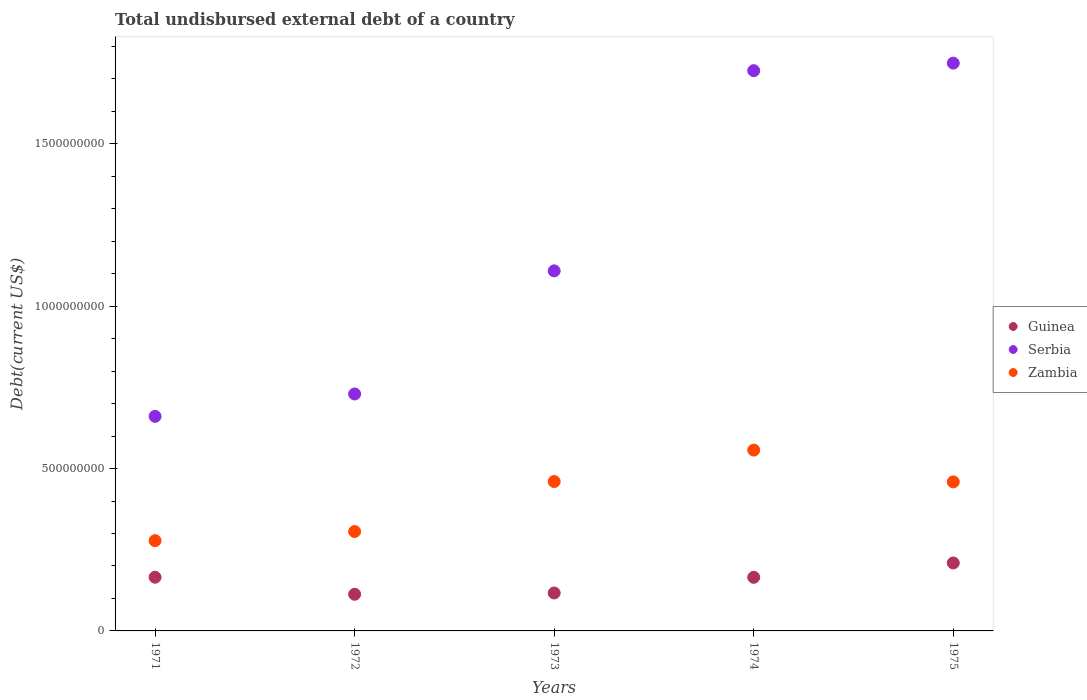What is the total undisbursed external debt in Serbia in 1972?
Ensure brevity in your answer.  7.30e+08. Across all years, what is the maximum total undisbursed external debt in Serbia?
Ensure brevity in your answer.  1.75e+09. Across all years, what is the minimum total undisbursed external debt in Serbia?
Offer a very short reply. 6.61e+08. In which year was the total undisbursed external debt in Serbia maximum?
Your answer should be very brief. 1975. In which year was the total undisbursed external debt in Zambia minimum?
Provide a succinct answer. 1971. What is the total total undisbursed external debt in Serbia in the graph?
Make the answer very short. 5.97e+09. What is the difference between the total undisbursed external debt in Serbia in 1974 and that in 1975?
Your answer should be compact. -2.32e+07. What is the difference between the total undisbursed external debt in Guinea in 1972 and the total undisbursed external debt in Serbia in 1974?
Give a very brief answer. -1.61e+09. What is the average total undisbursed external debt in Zambia per year?
Provide a succinct answer. 4.12e+08. In the year 1975, what is the difference between the total undisbursed external debt in Guinea and total undisbursed external debt in Zambia?
Offer a very short reply. -2.50e+08. In how many years, is the total undisbursed external debt in Zambia greater than 800000000 US$?
Provide a succinct answer. 0. What is the ratio of the total undisbursed external debt in Guinea in 1971 to that in 1972?
Make the answer very short. 1.46. Is the total undisbursed external debt in Guinea in 1971 less than that in 1974?
Ensure brevity in your answer.  No. What is the difference between the highest and the second highest total undisbursed external debt in Guinea?
Keep it short and to the point. 4.39e+07. What is the difference between the highest and the lowest total undisbursed external debt in Serbia?
Provide a short and direct response. 1.09e+09. Is the sum of the total undisbursed external debt in Guinea in 1971 and 1972 greater than the maximum total undisbursed external debt in Zambia across all years?
Provide a succinct answer. No. Is it the case that in every year, the sum of the total undisbursed external debt in Zambia and total undisbursed external debt in Serbia  is greater than the total undisbursed external debt in Guinea?
Provide a succinct answer. Yes. Is the total undisbursed external debt in Serbia strictly greater than the total undisbursed external debt in Zambia over the years?
Your answer should be very brief. Yes. How many dotlines are there?
Your answer should be very brief. 3. Does the graph contain any zero values?
Offer a terse response. No. Does the graph contain grids?
Offer a very short reply. No. Where does the legend appear in the graph?
Give a very brief answer. Center right. What is the title of the graph?
Your response must be concise. Total undisbursed external debt of a country. What is the label or title of the Y-axis?
Offer a very short reply. Debt(current US$). What is the Debt(current US$) of Guinea in 1971?
Your response must be concise. 1.65e+08. What is the Debt(current US$) of Serbia in 1971?
Your response must be concise. 6.61e+08. What is the Debt(current US$) of Zambia in 1971?
Keep it short and to the point. 2.78e+08. What is the Debt(current US$) of Guinea in 1972?
Provide a short and direct response. 1.13e+08. What is the Debt(current US$) in Serbia in 1972?
Ensure brevity in your answer.  7.30e+08. What is the Debt(current US$) of Zambia in 1972?
Your response must be concise. 3.06e+08. What is the Debt(current US$) in Guinea in 1973?
Your response must be concise. 1.17e+08. What is the Debt(current US$) of Serbia in 1973?
Ensure brevity in your answer.  1.11e+09. What is the Debt(current US$) of Zambia in 1973?
Offer a very short reply. 4.60e+08. What is the Debt(current US$) of Guinea in 1974?
Give a very brief answer. 1.65e+08. What is the Debt(current US$) of Serbia in 1974?
Offer a very short reply. 1.73e+09. What is the Debt(current US$) of Zambia in 1974?
Give a very brief answer. 5.57e+08. What is the Debt(current US$) of Guinea in 1975?
Your answer should be compact. 2.09e+08. What is the Debt(current US$) in Serbia in 1975?
Your answer should be compact. 1.75e+09. What is the Debt(current US$) of Zambia in 1975?
Make the answer very short. 4.59e+08. Across all years, what is the maximum Debt(current US$) of Guinea?
Your answer should be compact. 2.09e+08. Across all years, what is the maximum Debt(current US$) of Serbia?
Provide a succinct answer. 1.75e+09. Across all years, what is the maximum Debt(current US$) in Zambia?
Your answer should be very brief. 5.57e+08. Across all years, what is the minimum Debt(current US$) of Guinea?
Provide a short and direct response. 1.13e+08. Across all years, what is the minimum Debt(current US$) in Serbia?
Offer a terse response. 6.61e+08. Across all years, what is the minimum Debt(current US$) of Zambia?
Offer a very short reply. 2.78e+08. What is the total Debt(current US$) of Guinea in the graph?
Ensure brevity in your answer.  7.70e+08. What is the total Debt(current US$) of Serbia in the graph?
Give a very brief answer. 5.97e+09. What is the total Debt(current US$) of Zambia in the graph?
Make the answer very short. 2.06e+09. What is the difference between the Debt(current US$) in Guinea in 1971 and that in 1972?
Offer a very short reply. 5.25e+07. What is the difference between the Debt(current US$) of Serbia in 1971 and that in 1972?
Offer a terse response. -6.89e+07. What is the difference between the Debt(current US$) in Zambia in 1971 and that in 1972?
Make the answer very short. -2.82e+07. What is the difference between the Debt(current US$) of Guinea in 1971 and that in 1973?
Your answer should be very brief. 4.86e+07. What is the difference between the Debt(current US$) in Serbia in 1971 and that in 1973?
Make the answer very short. -4.48e+08. What is the difference between the Debt(current US$) of Zambia in 1971 and that in 1973?
Your response must be concise. -1.82e+08. What is the difference between the Debt(current US$) of Guinea in 1971 and that in 1974?
Your answer should be compact. 3.37e+05. What is the difference between the Debt(current US$) of Serbia in 1971 and that in 1974?
Offer a very short reply. -1.06e+09. What is the difference between the Debt(current US$) in Zambia in 1971 and that in 1974?
Provide a succinct answer. -2.79e+08. What is the difference between the Debt(current US$) of Guinea in 1971 and that in 1975?
Provide a succinct answer. -4.39e+07. What is the difference between the Debt(current US$) in Serbia in 1971 and that in 1975?
Your answer should be very brief. -1.09e+09. What is the difference between the Debt(current US$) in Zambia in 1971 and that in 1975?
Provide a succinct answer. -1.81e+08. What is the difference between the Debt(current US$) in Guinea in 1972 and that in 1973?
Give a very brief answer. -3.91e+06. What is the difference between the Debt(current US$) in Serbia in 1972 and that in 1973?
Ensure brevity in your answer.  -3.79e+08. What is the difference between the Debt(current US$) in Zambia in 1972 and that in 1973?
Give a very brief answer. -1.54e+08. What is the difference between the Debt(current US$) in Guinea in 1972 and that in 1974?
Ensure brevity in your answer.  -5.21e+07. What is the difference between the Debt(current US$) of Serbia in 1972 and that in 1974?
Keep it short and to the point. -9.96e+08. What is the difference between the Debt(current US$) of Zambia in 1972 and that in 1974?
Provide a succinct answer. -2.51e+08. What is the difference between the Debt(current US$) of Guinea in 1972 and that in 1975?
Your response must be concise. -9.64e+07. What is the difference between the Debt(current US$) of Serbia in 1972 and that in 1975?
Offer a very short reply. -1.02e+09. What is the difference between the Debt(current US$) in Zambia in 1972 and that in 1975?
Provide a short and direct response. -1.53e+08. What is the difference between the Debt(current US$) in Guinea in 1973 and that in 1974?
Ensure brevity in your answer.  -4.82e+07. What is the difference between the Debt(current US$) of Serbia in 1973 and that in 1974?
Provide a short and direct response. -6.17e+08. What is the difference between the Debt(current US$) in Zambia in 1973 and that in 1974?
Ensure brevity in your answer.  -9.68e+07. What is the difference between the Debt(current US$) in Guinea in 1973 and that in 1975?
Give a very brief answer. -9.25e+07. What is the difference between the Debt(current US$) in Serbia in 1973 and that in 1975?
Ensure brevity in your answer.  -6.40e+08. What is the difference between the Debt(current US$) in Zambia in 1973 and that in 1975?
Make the answer very short. 1.12e+06. What is the difference between the Debt(current US$) in Guinea in 1974 and that in 1975?
Your answer should be very brief. -4.42e+07. What is the difference between the Debt(current US$) of Serbia in 1974 and that in 1975?
Ensure brevity in your answer.  -2.32e+07. What is the difference between the Debt(current US$) of Zambia in 1974 and that in 1975?
Provide a succinct answer. 9.79e+07. What is the difference between the Debt(current US$) of Guinea in 1971 and the Debt(current US$) of Serbia in 1972?
Your answer should be compact. -5.64e+08. What is the difference between the Debt(current US$) of Guinea in 1971 and the Debt(current US$) of Zambia in 1972?
Make the answer very short. -1.41e+08. What is the difference between the Debt(current US$) in Serbia in 1971 and the Debt(current US$) in Zambia in 1972?
Your response must be concise. 3.55e+08. What is the difference between the Debt(current US$) in Guinea in 1971 and the Debt(current US$) in Serbia in 1973?
Keep it short and to the point. -9.44e+08. What is the difference between the Debt(current US$) of Guinea in 1971 and the Debt(current US$) of Zambia in 1973?
Provide a succinct answer. -2.95e+08. What is the difference between the Debt(current US$) in Serbia in 1971 and the Debt(current US$) in Zambia in 1973?
Keep it short and to the point. 2.01e+08. What is the difference between the Debt(current US$) of Guinea in 1971 and the Debt(current US$) of Serbia in 1974?
Your answer should be compact. -1.56e+09. What is the difference between the Debt(current US$) in Guinea in 1971 and the Debt(current US$) in Zambia in 1974?
Provide a short and direct response. -3.92e+08. What is the difference between the Debt(current US$) in Serbia in 1971 and the Debt(current US$) in Zambia in 1974?
Keep it short and to the point. 1.04e+08. What is the difference between the Debt(current US$) in Guinea in 1971 and the Debt(current US$) in Serbia in 1975?
Make the answer very short. -1.58e+09. What is the difference between the Debt(current US$) in Guinea in 1971 and the Debt(current US$) in Zambia in 1975?
Keep it short and to the point. -2.94e+08. What is the difference between the Debt(current US$) of Serbia in 1971 and the Debt(current US$) of Zambia in 1975?
Offer a very short reply. 2.02e+08. What is the difference between the Debt(current US$) in Guinea in 1972 and the Debt(current US$) in Serbia in 1973?
Ensure brevity in your answer.  -9.96e+08. What is the difference between the Debt(current US$) in Guinea in 1972 and the Debt(current US$) in Zambia in 1973?
Provide a succinct answer. -3.47e+08. What is the difference between the Debt(current US$) of Serbia in 1972 and the Debt(current US$) of Zambia in 1973?
Provide a short and direct response. 2.70e+08. What is the difference between the Debt(current US$) in Guinea in 1972 and the Debt(current US$) in Serbia in 1974?
Offer a very short reply. -1.61e+09. What is the difference between the Debt(current US$) of Guinea in 1972 and the Debt(current US$) of Zambia in 1974?
Offer a terse response. -4.44e+08. What is the difference between the Debt(current US$) in Serbia in 1972 and the Debt(current US$) in Zambia in 1974?
Your answer should be compact. 1.73e+08. What is the difference between the Debt(current US$) in Guinea in 1972 and the Debt(current US$) in Serbia in 1975?
Provide a succinct answer. -1.64e+09. What is the difference between the Debt(current US$) in Guinea in 1972 and the Debt(current US$) in Zambia in 1975?
Provide a short and direct response. -3.46e+08. What is the difference between the Debt(current US$) of Serbia in 1972 and the Debt(current US$) of Zambia in 1975?
Provide a succinct answer. 2.71e+08. What is the difference between the Debt(current US$) in Guinea in 1973 and the Debt(current US$) in Serbia in 1974?
Provide a short and direct response. -1.61e+09. What is the difference between the Debt(current US$) in Guinea in 1973 and the Debt(current US$) in Zambia in 1974?
Ensure brevity in your answer.  -4.40e+08. What is the difference between the Debt(current US$) in Serbia in 1973 and the Debt(current US$) in Zambia in 1974?
Provide a short and direct response. 5.52e+08. What is the difference between the Debt(current US$) in Guinea in 1973 and the Debt(current US$) in Serbia in 1975?
Make the answer very short. -1.63e+09. What is the difference between the Debt(current US$) in Guinea in 1973 and the Debt(current US$) in Zambia in 1975?
Your answer should be very brief. -3.42e+08. What is the difference between the Debt(current US$) of Serbia in 1973 and the Debt(current US$) of Zambia in 1975?
Make the answer very short. 6.50e+08. What is the difference between the Debt(current US$) in Guinea in 1974 and the Debt(current US$) in Serbia in 1975?
Offer a very short reply. -1.58e+09. What is the difference between the Debt(current US$) in Guinea in 1974 and the Debt(current US$) in Zambia in 1975?
Keep it short and to the point. -2.94e+08. What is the difference between the Debt(current US$) in Serbia in 1974 and the Debt(current US$) in Zambia in 1975?
Make the answer very short. 1.27e+09. What is the average Debt(current US$) in Guinea per year?
Offer a terse response. 1.54e+08. What is the average Debt(current US$) in Serbia per year?
Your answer should be very brief. 1.19e+09. What is the average Debt(current US$) in Zambia per year?
Your response must be concise. 4.12e+08. In the year 1971, what is the difference between the Debt(current US$) of Guinea and Debt(current US$) of Serbia?
Make the answer very short. -4.95e+08. In the year 1971, what is the difference between the Debt(current US$) of Guinea and Debt(current US$) of Zambia?
Your answer should be very brief. -1.13e+08. In the year 1971, what is the difference between the Debt(current US$) in Serbia and Debt(current US$) in Zambia?
Your answer should be very brief. 3.83e+08. In the year 1972, what is the difference between the Debt(current US$) of Guinea and Debt(current US$) of Serbia?
Give a very brief answer. -6.17e+08. In the year 1972, what is the difference between the Debt(current US$) of Guinea and Debt(current US$) of Zambia?
Provide a succinct answer. -1.93e+08. In the year 1972, what is the difference between the Debt(current US$) of Serbia and Debt(current US$) of Zambia?
Your answer should be compact. 4.24e+08. In the year 1973, what is the difference between the Debt(current US$) of Guinea and Debt(current US$) of Serbia?
Your response must be concise. -9.92e+08. In the year 1973, what is the difference between the Debt(current US$) of Guinea and Debt(current US$) of Zambia?
Offer a terse response. -3.43e+08. In the year 1973, what is the difference between the Debt(current US$) in Serbia and Debt(current US$) in Zambia?
Give a very brief answer. 6.49e+08. In the year 1974, what is the difference between the Debt(current US$) of Guinea and Debt(current US$) of Serbia?
Your answer should be very brief. -1.56e+09. In the year 1974, what is the difference between the Debt(current US$) in Guinea and Debt(current US$) in Zambia?
Give a very brief answer. -3.92e+08. In the year 1974, what is the difference between the Debt(current US$) of Serbia and Debt(current US$) of Zambia?
Your answer should be compact. 1.17e+09. In the year 1975, what is the difference between the Debt(current US$) in Guinea and Debt(current US$) in Serbia?
Provide a short and direct response. -1.54e+09. In the year 1975, what is the difference between the Debt(current US$) of Guinea and Debt(current US$) of Zambia?
Ensure brevity in your answer.  -2.50e+08. In the year 1975, what is the difference between the Debt(current US$) of Serbia and Debt(current US$) of Zambia?
Make the answer very short. 1.29e+09. What is the ratio of the Debt(current US$) of Guinea in 1971 to that in 1972?
Your response must be concise. 1.46. What is the ratio of the Debt(current US$) of Serbia in 1971 to that in 1972?
Ensure brevity in your answer.  0.91. What is the ratio of the Debt(current US$) of Zambia in 1971 to that in 1972?
Give a very brief answer. 0.91. What is the ratio of the Debt(current US$) in Guinea in 1971 to that in 1973?
Offer a very short reply. 1.42. What is the ratio of the Debt(current US$) of Serbia in 1971 to that in 1973?
Ensure brevity in your answer.  0.6. What is the ratio of the Debt(current US$) in Zambia in 1971 to that in 1973?
Make the answer very short. 0.6. What is the ratio of the Debt(current US$) of Guinea in 1971 to that in 1974?
Provide a succinct answer. 1. What is the ratio of the Debt(current US$) of Serbia in 1971 to that in 1974?
Offer a terse response. 0.38. What is the ratio of the Debt(current US$) in Zambia in 1971 to that in 1974?
Provide a short and direct response. 0.5. What is the ratio of the Debt(current US$) of Guinea in 1971 to that in 1975?
Offer a very short reply. 0.79. What is the ratio of the Debt(current US$) of Serbia in 1971 to that in 1975?
Offer a very short reply. 0.38. What is the ratio of the Debt(current US$) in Zambia in 1971 to that in 1975?
Provide a short and direct response. 0.61. What is the ratio of the Debt(current US$) in Guinea in 1972 to that in 1973?
Give a very brief answer. 0.97. What is the ratio of the Debt(current US$) of Serbia in 1972 to that in 1973?
Offer a very short reply. 0.66. What is the ratio of the Debt(current US$) in Zambia in 1972 to that in 1973?
Ensure brevity in your answer.  0.67. What is the ratio of the Debt(current US$) of Guinea in 1972 to that in 1974?
Provide a short and direct response. 0.68. What is the ratio of the Debt(current US$) in Serbia in 1972 to that in 1974?
Provide a succinct answer. 0.42. What is the ratio of the Debt(current US$) of Zambia in 1972 to that in 1974?
Provide a succinct answer. 0.55. What is the ratio of the Debt(current US$) in Guinea in 1972 to that in 1975?
Your answer should be compact. 0.54. What is the ratio of the Debt(current US$) of Serbia in 1972 to that in 1975?
Offer a terse response. 0.42. What is the ratio of the Debt(current US$) in Zambia in 1972 to that in 1975?
Offer a very short reply. 0.67. What is the ratio of the Debt(current US$) of Guinea in 1973 to that in 1974?
Offer a very short reply. 0.71. What is the ratio of the Debt(current US$) of Serbia in 1973 to that in 1974?
Give a very brief answer. 0.64. What is the ratio of the Debt(current US$) in Zambia in 1973 to that in 1974?
Ensure brevity in your answer.  0.83. What is the ratio of the Debt(current US$) in Guinea in 1973 to that in 1975?
Keep it short and to the point. 0.56. What is the ratio of the Debt(current US$) in Serbia in 1973 to that in 1975?
Your answer should be compact. 0.63. What is the ratio of the Debt(current US$) of Guinea in 1974 to that in 1975?
Your answer should be very brief. 0.79. What is the ratio of the Debt(current US$) in Serbia in 1974 to that in 1975?
Provide a short and direct response. 0.99. What is the ratio of the Debt(current US$) of Zambia in 1974 to that in 1975?
Your response must be concise. 1.21. What is the difference between the highest and the second highest Debt(current US$) in Guinea?
Keep it short and to the point. 4.39e+07. What is the difference between the highest and the second highest Debt(current US$) of Serbia?
Your answer should be compact. 2.32e+07. What is the difference between the highest and the second highest Debt(current US$) in Zambia?
Ensure brevity in your answer.  9.68e+07. What is the difference between the highest and the lowest Debt(current US$) in Guinea?
Provide a succinct answer. 9.64e+07. What is the difference between the highest and the lowest Debt(current US$) in Serbia?
Provide a succinct answer. 1.09e+09. What is the difference between the highest and the lowest Debt(current US$) in Zambia?
Offer a terse response. 2.79e+08. 